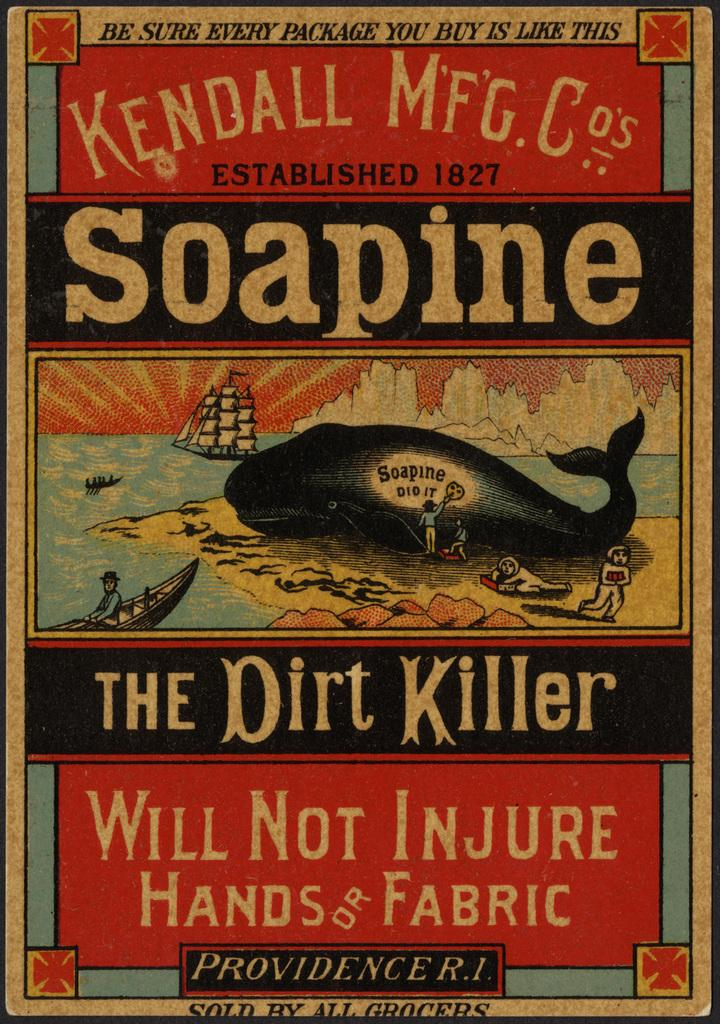<image>
Give a short and clear explanation of the subsequent image. An old fashioned advertisement for Soapine, The Dirt Killer has a picture of a whale on a beach with people cleaning it. 